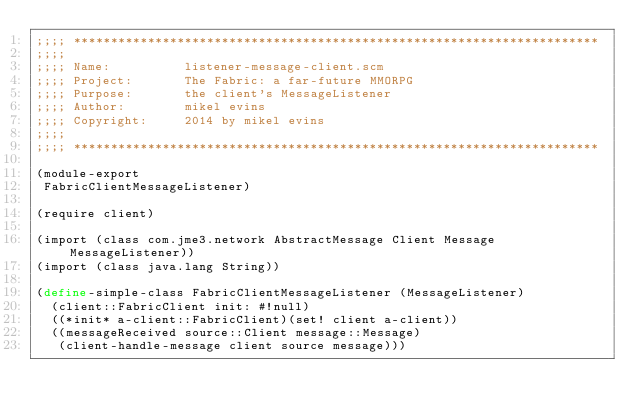Convert code to text. <code><loc_0><loc_0><loc_500><loc_500><_Scheme_>;;;; ***********************************************************************
;;;;
;;;; Name:          listener-message-client.scm
;;;; Project:       The Fabric: a far-future MMORPG
;;;; Purpose:       the client's MessageListener
;;;; Author:        mikel evins
;;;; Copyright:     2014 by mikel evins
;;;;
;;;; ***********************************************************************

(module-export
 FabricClientMessageListener)

(require client)

(import (class com.jme3.network AbstractMessage Client Message MessageListener))
(import (class java.lang String))

(define-simple-class FabricClientMessageListener (MessageListener)
  (client::FabricClient init: #!null)
  ((*init* a-client::FabricClient)(set! client a-client))
  ((messageReceived source::Client message::Message)
   (client-handle-message client source message)))

</code> 